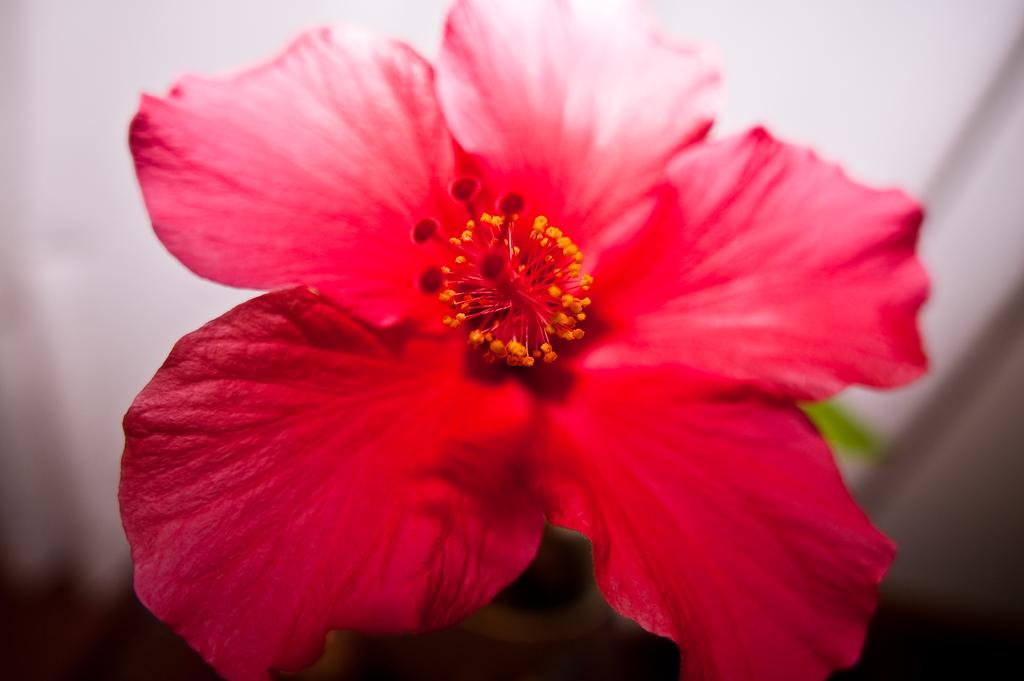What is the main subject of the image? There is a flower in the image. What color is the flower? The flower is red in color. Can you describe the background of the image? The background of the image is blurred. Is there a lake visible in the image? No, there is no lake present in the image. The image only features a red flower with a blurred background. 